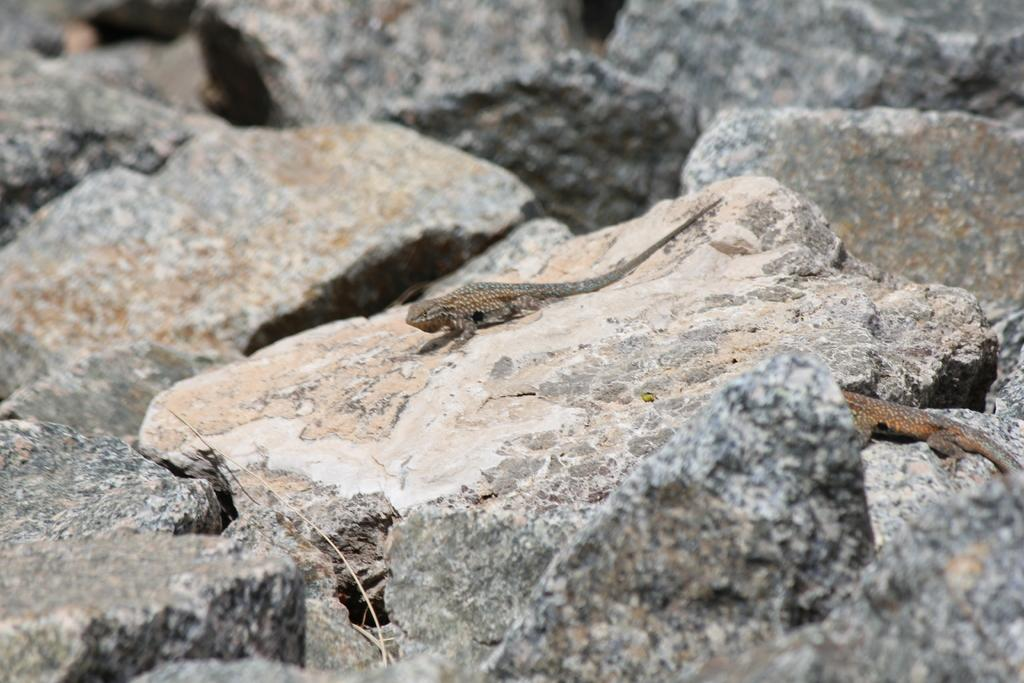What type of natural elements can be seen in the image? There are rocks in the image. What type of animals are present in the image? There are two lizards in the image. What type of wall can be seen in the image? There is no wall present in the image; it features rocks and lizards. How many clovers are visible in the image? There are no clovers present in the image. 